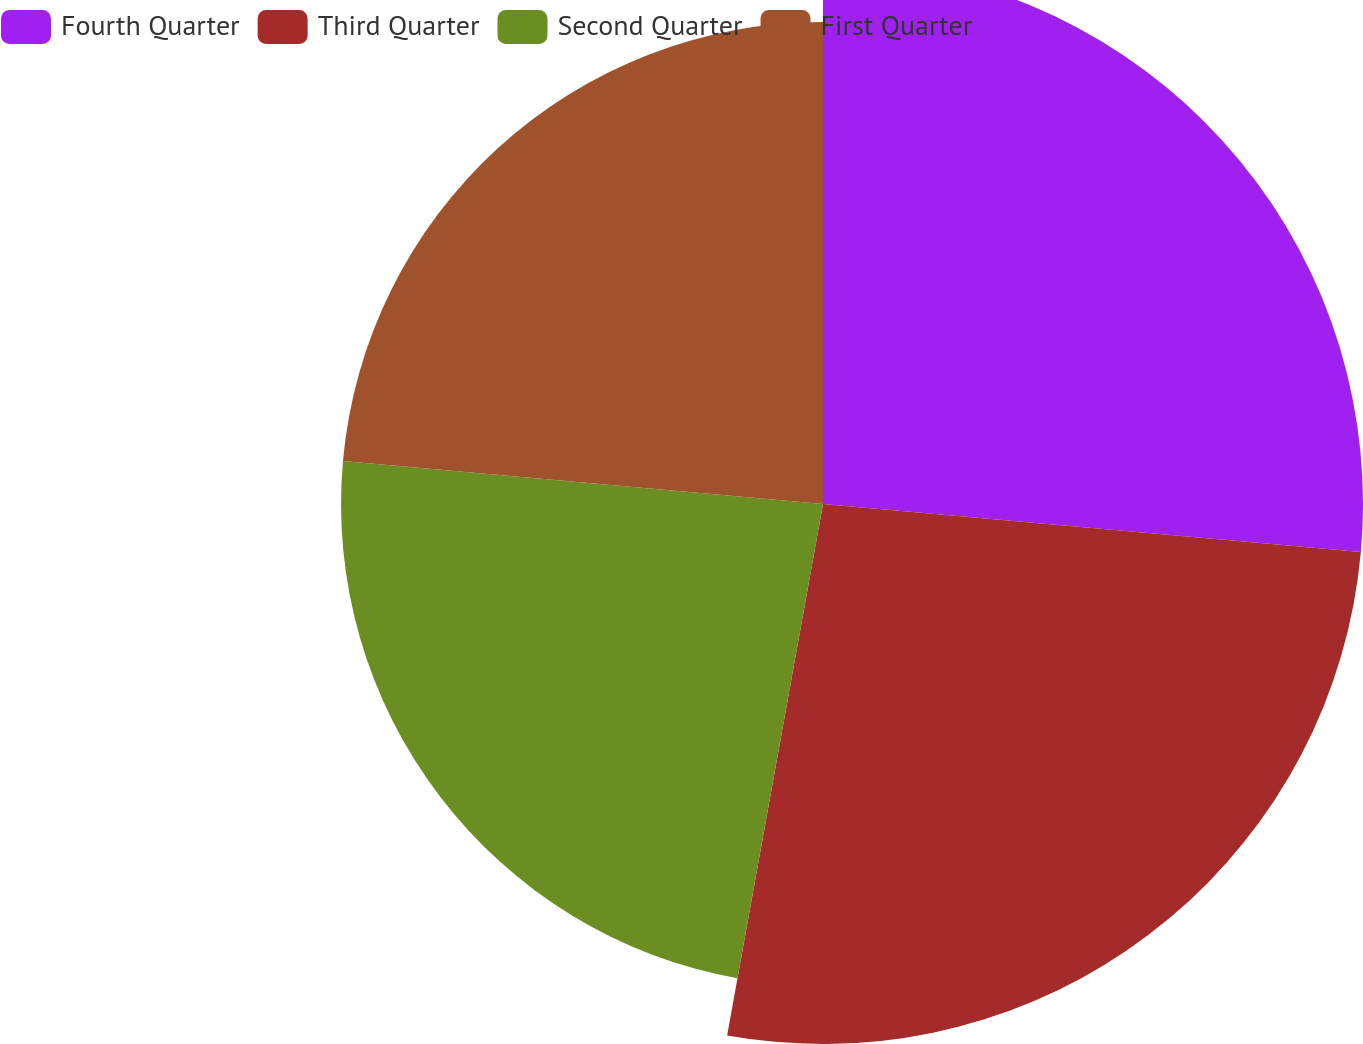<chart> <loc_0><loc_0><loc_500><loc_500><pie_chart><fcel>Fourth Quarter<fcel>Third Quarter<fcel>Second Quarter<fcel>First Quarter<nl><fcel>26.42%<fcel>26.42%<fcel>23.58%<fcel>23.58%<nl></chart> 